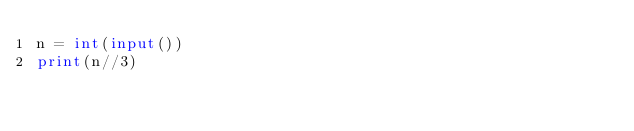<code> <loc_0><loc_0><loc_500><loc_500><_Python_>n = int(input())
print(n//3)</code> 